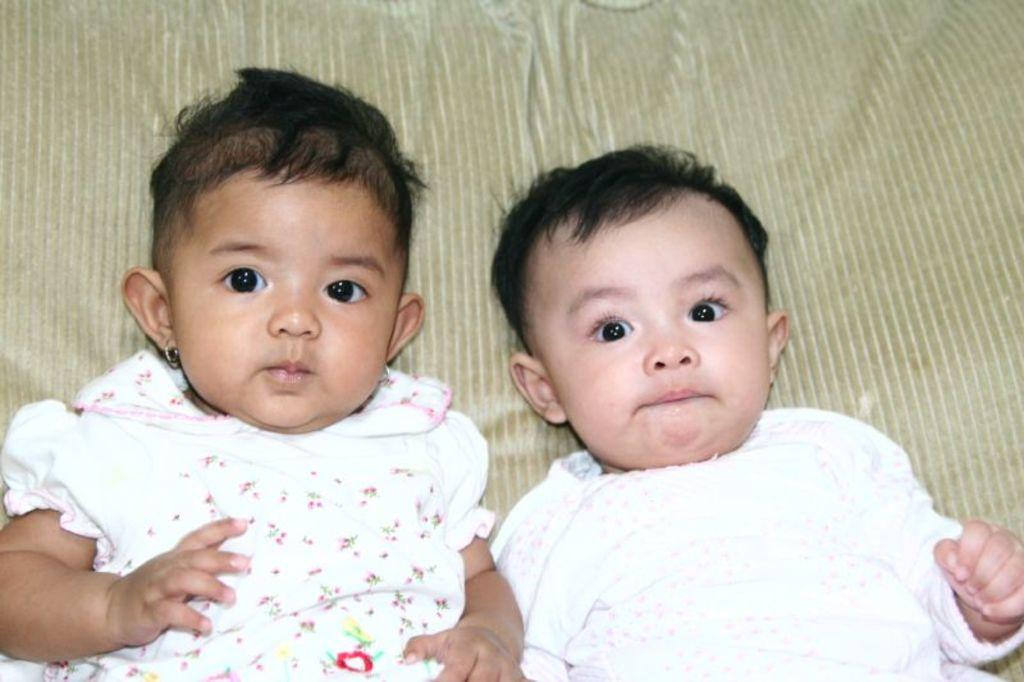What is the main subject of the image? The main subject of the image is two babies. Where are the babies located in the image? The babies are in the center of the image. What can be seen in the background of the image? There is a blanket in the background of the image. What type of mouth can be seen on the box in the image? There is no box present in the image, and therefore no mouth on a box can be observed. 